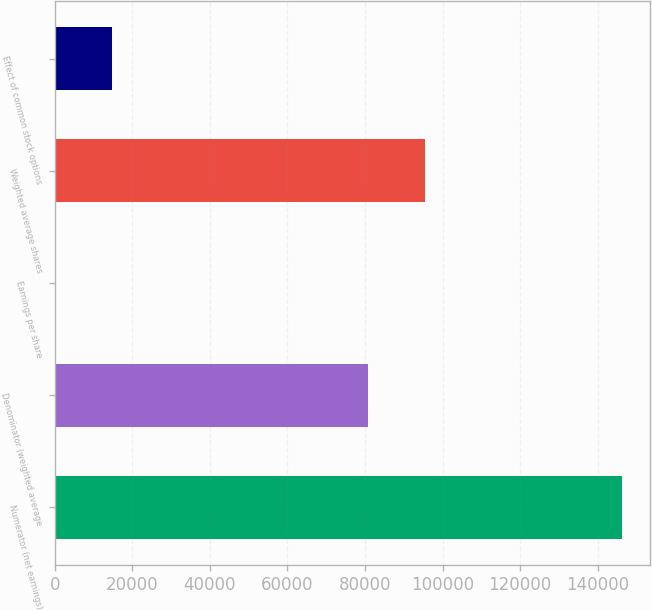<chart> <loc_0><loc_0><loc_500><loc_500><bar_chart><fcel>Numerator (net earnings)<fcel>Denominator (weighted average<fcel>Earnings per share<fcel>Weighted average shares<fcel>Effect of common stock options<nl><fcel>146256<fcel>80771<fcel>1.81<fcel>95396.4<fcel>14627.2<nl></chart> 